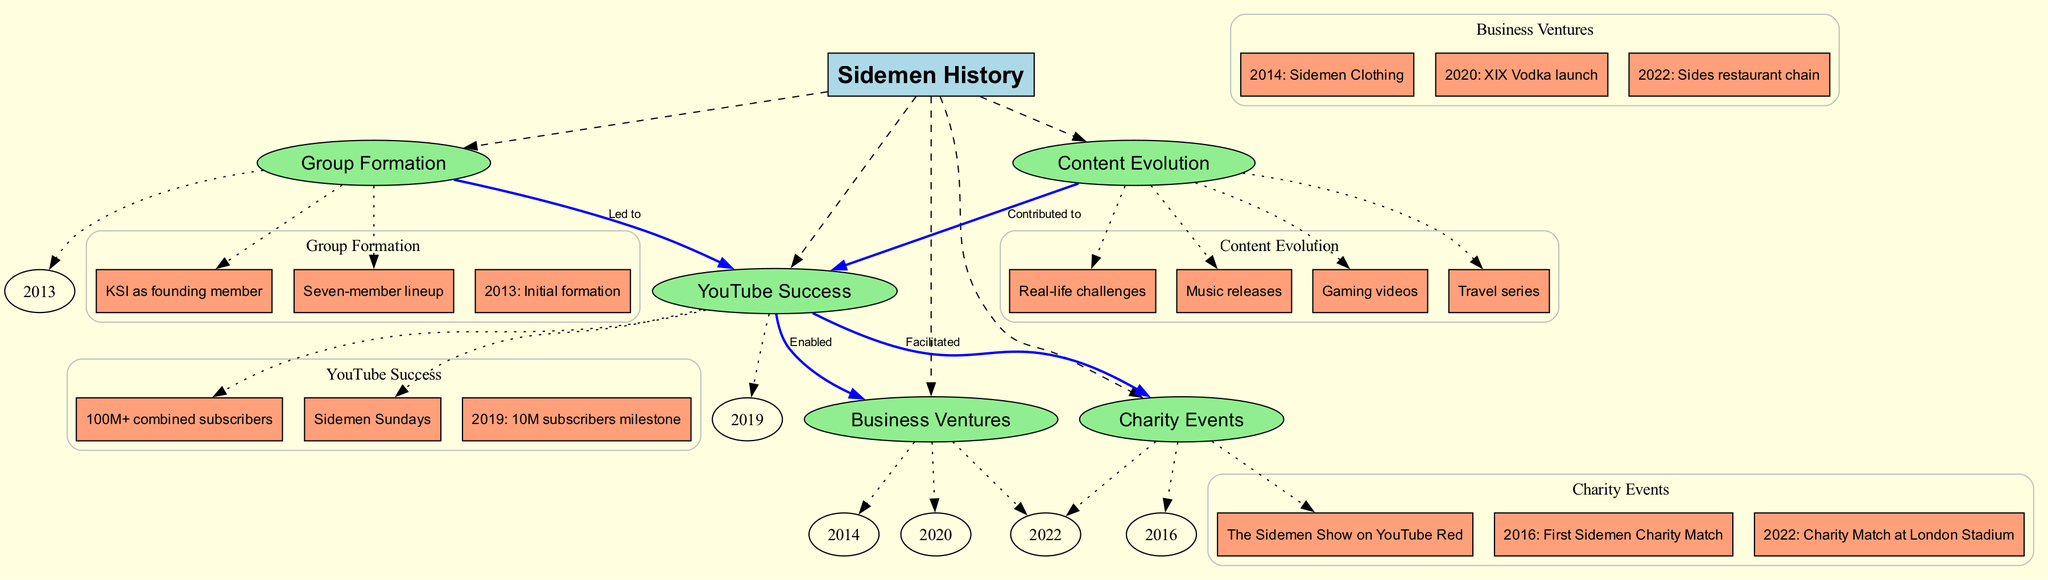What year was the Sidemen formed? The diagram shows that the Sidemen were initially formed in 2013. This information is located under the "Group Formation" main node and is clearly labeled as a sub-node.
Answer: 2013 How many subscribers did the Sidemen reach in 2019? According to the diagram, the Sidemen reached a milestone of 10 million subscribers in 2019. This is indicated under the "YouTube Success" main node.
Answer: 10M What is the relationship between "YouTube Success" and "Business Ventures"? The diagram indicates that "YouTube Success" enabled "Business Ventures." This connection is depicted by an edge labeled "Enabled" between the two nodes.
Answer: Enabled Which event corresponds to the first Sidemen Charity Match? The first Sidemen Charity Match occurred in 2016, as indicated in the "Charity Events" main node. This year is listed as a sub-node under that section.
Answer: 2016 What type of content contributed to the Sidemen's YouTube success? The diagram shows that content evolution, including gaming videos, real-life challenges, travel series, and music releases, contributed to YouTube success. This is described under the "Content Evolution" node.
Answer: Content Evolution How many main nodes are present in the concept map? The diagram lists five main nodes related to Sidemen's history: Group Formation, YouTube Success, Business Ventures, Charity Events, and Content Evolution. Therefore, the total number of main nodes is five.
Answer: 5 What business was launched in 2020 by the Sidemen? According to the diagram, XIX Vodka was launched in 2020, and this information can be found under the "Business Ventures" main node as one of its sub-nodes.
Answer: XIX Vodka What did "YouTube Success" facilitate for the Sidemen? The diagram shows that "YouTube Success" facilitated charity events, which is indicated by the edge labeled "Facilitated" connecting the two nodes.
Answer: Charity Events What led to the Sidemen's YouTube success? The diagram specifies that "Group Formation" led to "YouTube Success," as shown by the labeled edge between these two nodes in the connections section of the diagram.
Answer: Led to 